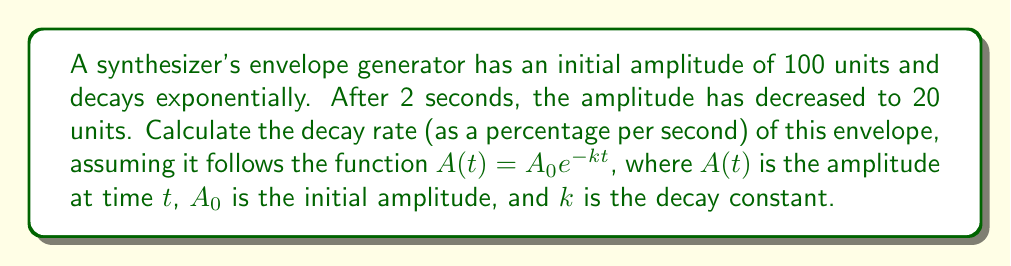Can you answer this question? 1) We're given the exponential decay function: $A(t) = A_0e^{-kt}$

2) We know:
   $A_0 = 100$ (initial amplitude)
   $A(2) = 20$ (amplitude after 2 seconds)
   $t = 2$ (time in seconds)

3) Let's substitute these values into the equation:
   $20 = 100e^{-k(2)}$

4) Divide both sides by 100:
   $\frac{1}{5} = e^{-2k}$

5) Take the natural log of both sides:
   $\ln(\frac{1}{5}) = -2k$

6) Solve for $k$:
   $k = -\frac{1}{2}\ln(\frac{1}{5}) = \frac{1}{2}\ln(5) \approx 0.8047$

7) The decay rate as a percentage per second is:
   $(1 - e^{-k}) \times 100\%$

8) Substitute our $k$ value:
   $(1 - e^{-0.8047}) \times 100\% \approx 55.26\%$
Answer: $55.26\%$ per second 